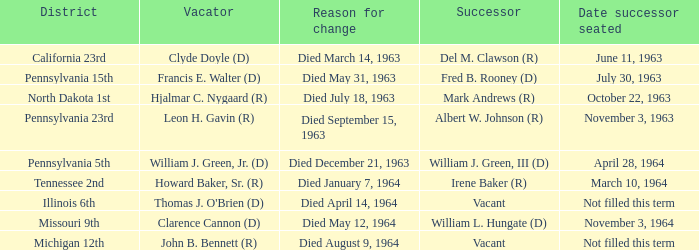What were the reasons for the changes in each district on august 9, 1964, when someone died? Michigan 12th. 